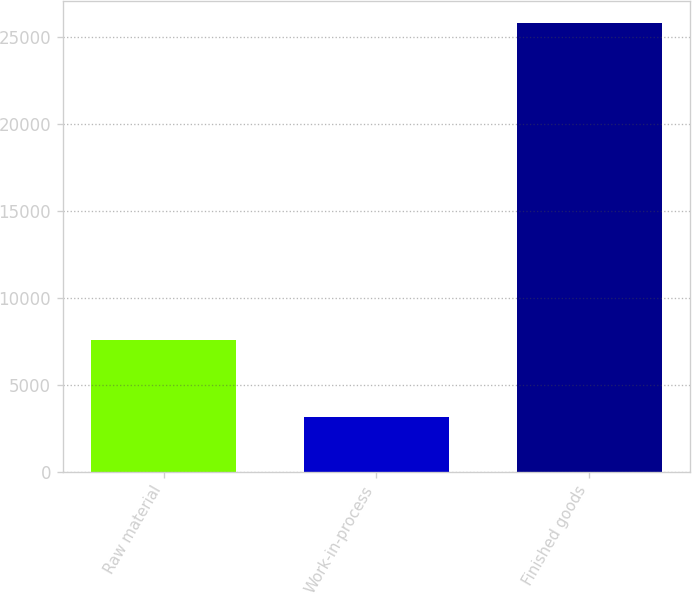Convert chart to OTSL. <chart><loc_0><loc_0><loc_500><loc_500><bar_chart><fcel>Raw material<fcel>Work-in-process<fcel>Finished goods<nl><fcel>7577<fcel>3139<fcel>25800<nl></chart> 